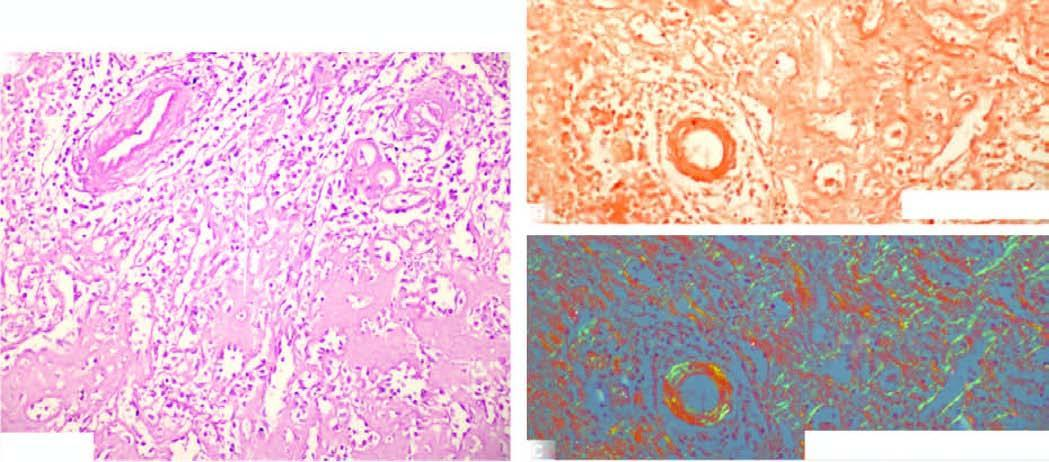what shows congophilia as seen by red-pink colour?
Answer the question using a single word or phrase. Congo staining colour 